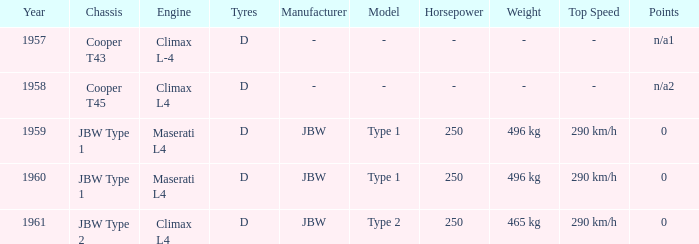What engine was in the year of 1961? Climax L4. 